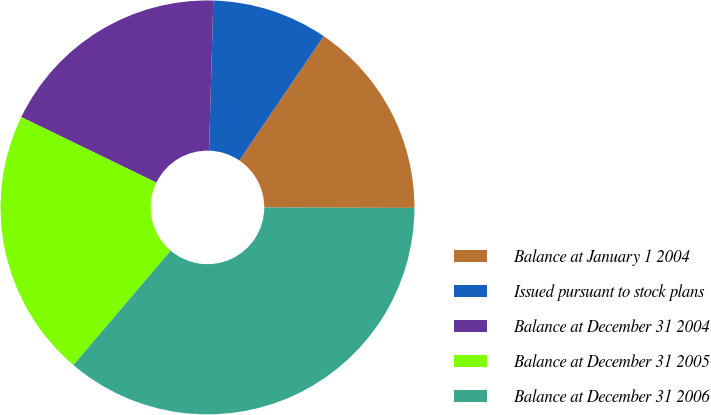Convert chart to OTSL. <chart><loc_0><loc_0><loc_500><loc_500><pie_chart><fcel>Balance at January 1 2004<fcel>Issued pursuant to stock plans<fcel>Balance at December 31 2004<fcel>Balance at December 31 2005<fcel>Balance at December 31 2006<nl><fcel>15.55%<fcel>9.04%<fcel>18.26%<fcel>20.97%<fcel>36.18%<nl></chart> 